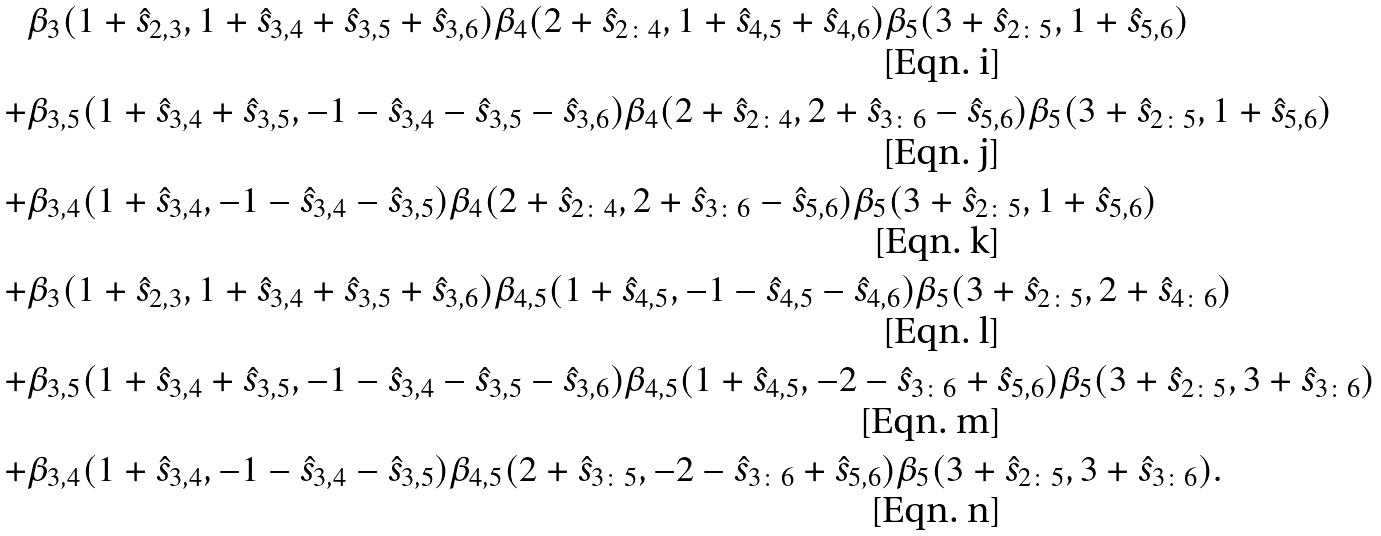<formula> <loc_0><loc_0><loc_500><loc_500>& \beta _ { 3 } ( 1 + \hat { s } _ { 2 , 3 } , 1 + \hat { s } _ { 3 , 4 } + \hat { s } _ { 3 , 5 } + \hat { s } _ { 3 , 6 } ) \beta _ { 4 } ( 2 + \hat { s } _ { 2 \colon 4 } , 1 + \hat { s } _ { 4 , 5 } + \hat { s } _ { 4 , 6 } ) \beta _ { 5 } ( 3 + \hat { s } _ { 2 \colon 5 } , 1 + \hat { s } _ { 5 , 6 } ) \\ + & \beta _ { 3 , 5 } ( 1 + \hat { s } _ { 3 , 4 } + \hat { s } _ { 3 , 5 } , - 1 - \hat { s } _ { 3 , 4 } - \hat { s } _ { 3 , 5 } - \hat { s } _ { 3 , 6 } ) \beta _ { 4 } ( 2 + \hat { s } _ { 2 \colon 4 } , 2 + \hat { s } _ { 3 \colon 6 } - \hat { s } _ { 5 , 6 } ) \beta _ { 5 } ( 3 + \hat { s } _ { 2 \colon 5 } , 1 + \hat { s } _ { 5 , 6 } ) \\ + & \beta _ { 3 , 4 } ( 1 + \hat { s } _ { 3 , 4 } , - 1 - \hat { s } _ { 3 , 4 } - \hat { s } _ { 3 , 5 } ) \beta _ { 4 } ( 2 + \hat { s } _ { 2 \colon 4 } , 2 + \hat { s } _ { 3 \colon 6 } - \hat { s } _ { 5 , 6 } ) \beta _ { 5 } ( 3 + \hat { s } _ { 2 \colon 5 } , 1 + \hat { s } _ { 5 , 6 } ) \\ + & \beta _ { 3 } ( 1 + \hat { s } _ { 2 , 3 } , 1 + \hat { s } _ { 3 , 4 } + \hat { s } _ { 3 , 5 } + \hat { s } _ { 3 , 6 } ) \beta _ { 4 , 5 } ( 1 + \hat { s } _ { 4 , 5 } , - 1 - \hat { s } _ { 4 , 5 } - \hat { s } _ { 4 , 6 } ) \beta _ { 5 } ( 3 + \hat { s } _ { 2 \colon 5 } , 2 + \hat { s } _ { 4 \colon 6 } ) \\ + & \beta _ { 3 , 5 } ( 1 + \hat { s } _ { 3 , 4 } + \hat { s } _ { 3 , 5 } , - 1 - \hat { s } _ { 3 , 4 } - \hat { s } _ { 3 , 5 } - \hat { s } _ { 3 , 6 } ) \beta _ { 4 , 5 } ( 1 + \hat { s } _ { 4 , 5 } , - 2 - \hat { s } _ { 3 \colon 6 } + \hat { s } _ { 5 , 6 } ) \beta _ { 5 } ( 3 + \hat { s } _ { 2 \colon 5 } , 3 + \hat { s } _ { 3 \colon 6 } ) \\ + & \beta _ { 3 , 4 } ( 1 + \hat { s } _ { 3 , 4 } , - 1 - \hat { s } _ { 3 , 4 } - \hat { s } _ { 3 , 5 } ) \beta _ { 4 , 5 } ( 2 + \hat { s } _ { 3 \colon 5 } , - 2 - \hat { s } _ { 3 \colon 6 } + \hat { s } _ { 5 , 6 } ) \beta _ { 5 } ( 3 + \hat { s } _ { 2 \colon 5 } , 3 + \hat { s } _ { 3 \colon 6 } ) .</formula> 